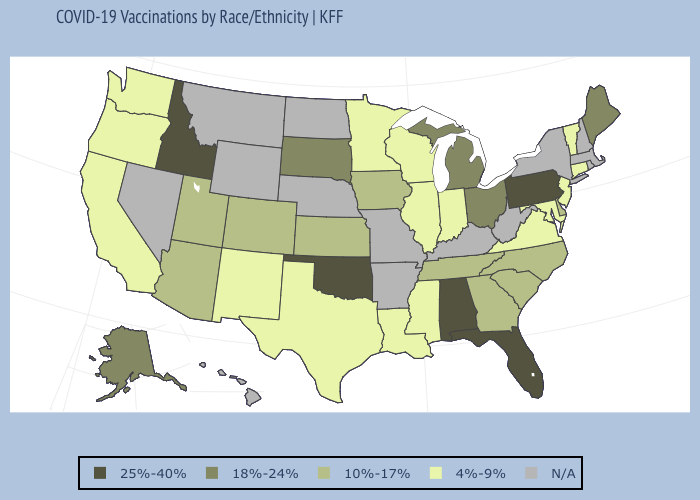Does Mississippi have the lowest value in the USA?
Concise answer only. Yes. Among the states that border Nevada , does Idaho have the highest value?
Be succinct. Yes. Name the states that have a value in the range N/A?
Short answer required. Arkansas, Hawaii, Kentucky, Massachusetts, Missouri, Montana, Nebraska, Nevada, New Hampshire, New York, North Dakota, Rhode Island, West Virginia, Wyoming. Name the states that have a value in the range 18%-24%?
Keep it brief. Alaska, Maine, Michigan, Ohio, South Dakota. What is the value of Missouri?
Be succinct. N/A. What is the value of Nevada?
Keep it brief. N/A. Which states have the lowest value in the West?
Give a very brief answer. California, New Mexico, Oregon, Washington. Which states have the highest value in the USA?
Give a very brief answer. Alabama, Florida, Idaho, Oklahoma, Pennsylvania. Name the states that have a value in the range 25%-40%?
Keep it brief. Alabama, Florida, Idaho, Oklahoma, Pennsylvania. Name the states that have a value in the range 10%-17%?
Short answer required. Arizona, Colorado, Delaware, Georgia, Iowa, Kansas, North Carolina, South Carolina, Tennessee, Utah. Does Maine have the lowest value in the Northeast?
Short answer required. No. Name the states that have a value in the range 4%-9%?
Short answer required. California, Connecticut, Illinois, Indiana, Louisiana, Maryland, Minnesota, Mississippi, New Jersey, New Mexico, Oregon, Texas, Vermont, Virginia, Washington, Wisconsin. What is the value of Michigan?
Keep it brief. 18%-24%. Does the map have missing data?
Give a very brief answer. Yes. Does Idaho have the highest value in the West?
Write a very short answer. Yes. 